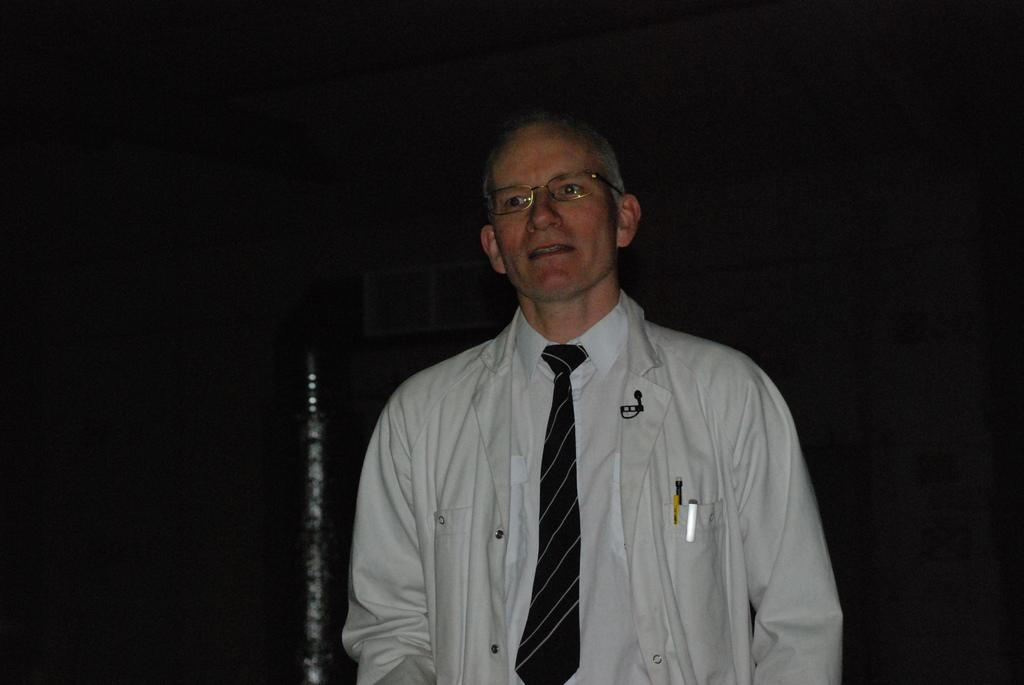Who is present in the image? There is a man in the image. What is the man wearing on his upper body? The man is wearing a white shirt and a white jacket. What type of accessory is the man wearing around his neck? The man is wearing a black tie. What can be observed about the lighting or color of the background in the image? The background of the image is dark. What type of rifle can be seen in the man's hand in the image? There is no rifle present in the image; the man is not holding any object. 